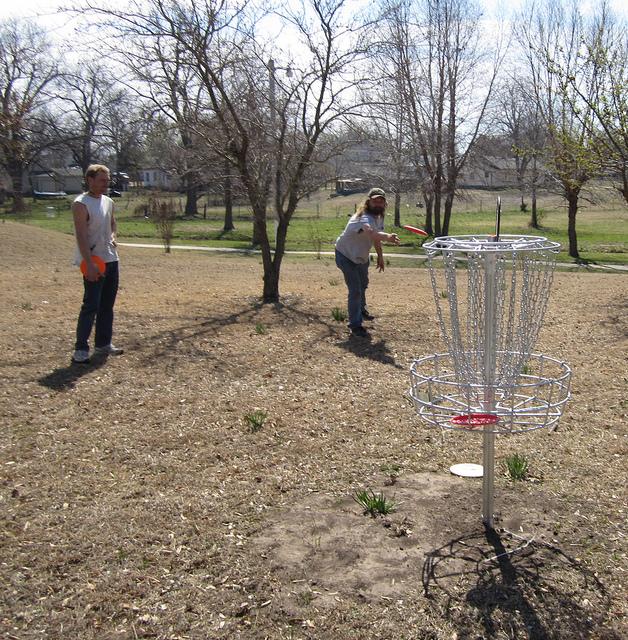Where are the men?
Be succinct. Park. Is the man throwing frisbee wearing jeans?
Quick response, please. Yes. How many men do you see?
Keep it brief. 2. 